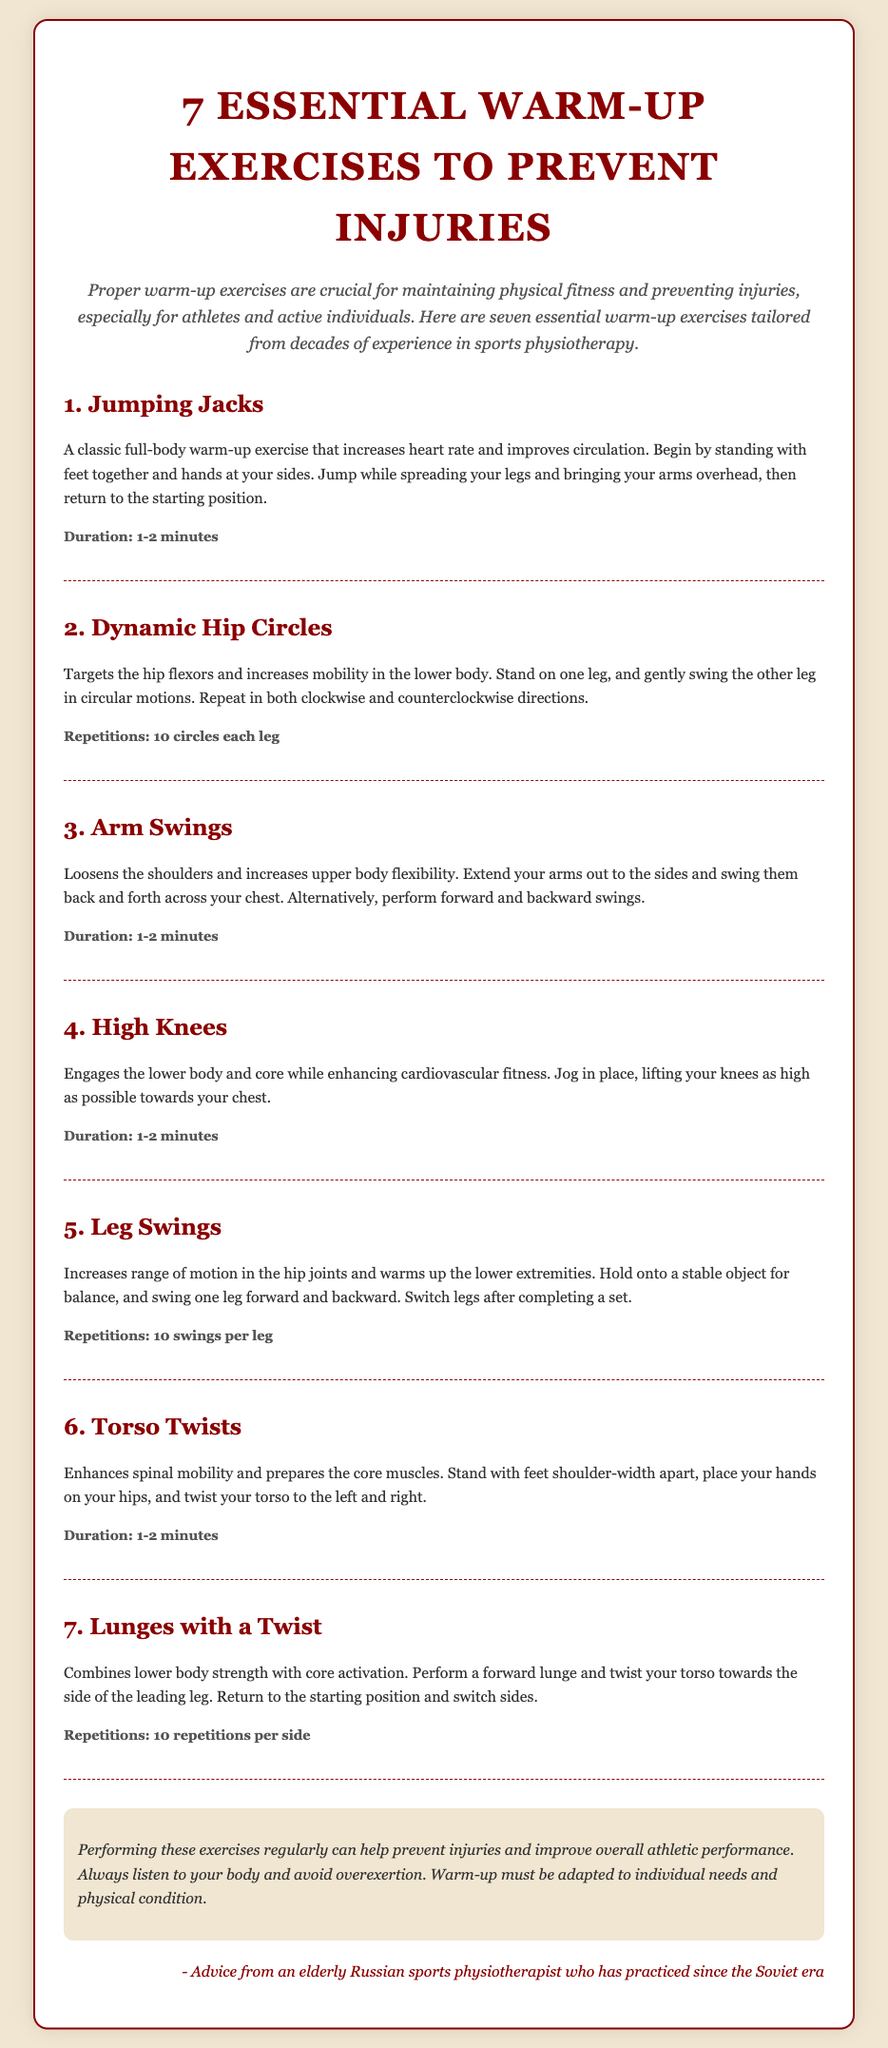What is the title of the document? The title is prominently displayed at the top of the document.
Answer: 7 Essential Warm-Up Exercises to Prevent Injuries How many warm-up exercises are listed? The number of warm-up exercises is mentioned in the title of the document.
Answer: 7 What is the duration for Jumping Jacks? The duration is specified directly after the description of the exercise.
Answer: 1-2 minutes What exercise targets the hip flexors? The exercise that focuses on the hip flexors is mentioned in the list of warm-up exercises.
Answer: Dynamic Hip Circles How many repetitions are suggested for Lunges with a Twist? The number of repetitions is stated in the description of the exercise.
Answer: 10 repetitions per side Which exercise enhances spinal mobility? The exercise that enhances spinal mobility is listed among the warm-up exercises.
Answer: Torso Twists What is a recommendation given at the end of the document? The recommendation is provided in a note section at the bottom of the document.
Answer: Perform these exercises regularly What is the primary purpose of these exercises? The purpose is explained in the introductory paragraph of the document.
Answer: Prevent injuries and improve overall athletic performance 